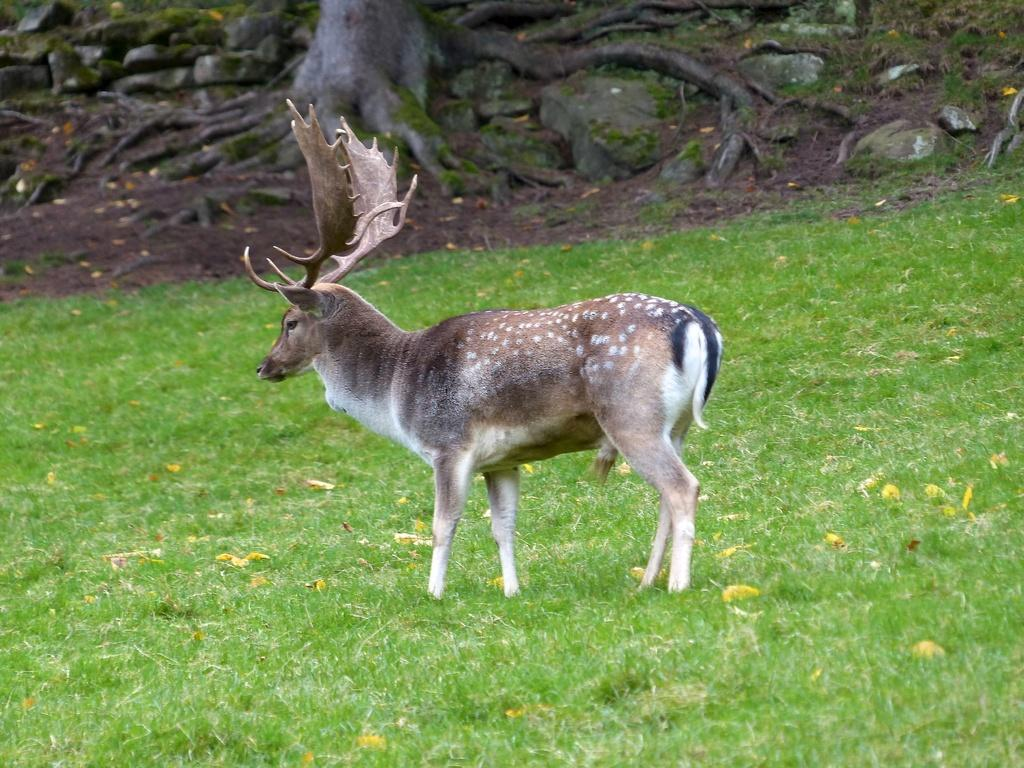What type of surface is covering the ground in the image? The ground in the image is covered with grass. What animal can be seen standing on the grass ground? There is a deer standing on the grass ground. What type of rail can be seen surrounding the deer in the image? There is no rail present in the image; the deer is standing on grass. 